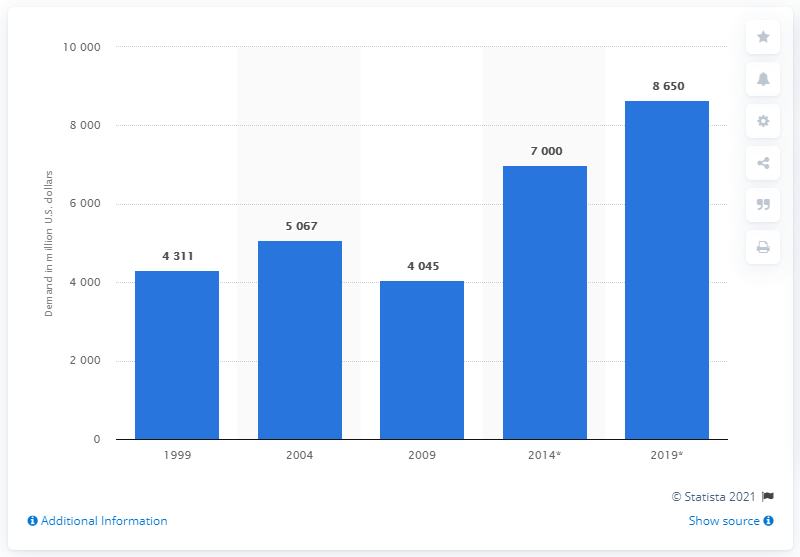Point out several critical features in this image. The projected amount of advanced flat glass demand in the United States in 2019 is estimated to be approximately 8,650 metric tons. In 1999, the advanced flat glass demand in the United States was 4,311 units. 